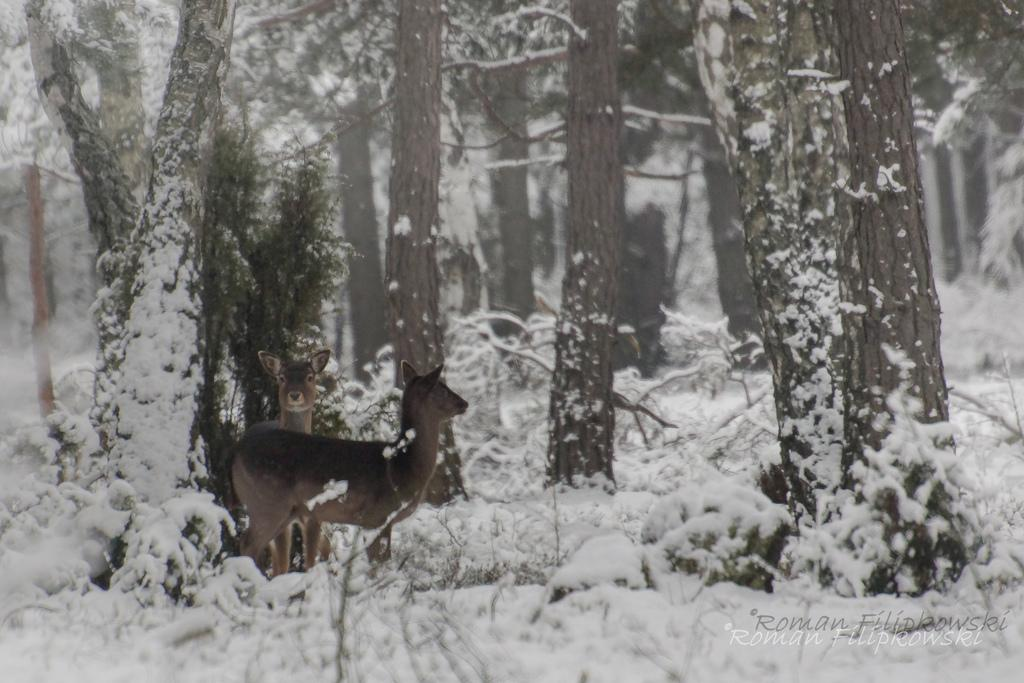How many animals are present in the image? There are two animals in the image. What are the animals doing in the image? The animals are standing. What colors are the animals? The animals are in black and brown color. What can be seen in the background of the image? There are trees in the image, and they are covered with snow. What color is the snow in the image? The snow is in white color. What type of brass instrument is the tree playing in the image? There is no brass instrument or tree playing an instrument in the image. 